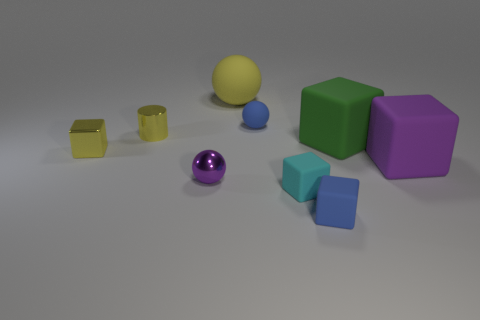What is the size of the blue object that is the same shape as the large yellow rubber object?
Provide a short and direct response. Small. Is the ball in front of the blue sphere made of the same material as the small blue object in front of the green rubber block?
Make the answer very short. No. Are there fewer shiny spheres to the left of the purple metallic object than small shiny objects?
Ensure brevity in your answer.  Yes. Is there anything else that is the same shape as the small purple shiny thing?
Provide a succinct answer. Yes. There is another big thing that is the same shape as the big green thing; what is its color?
Give a very brief answer. Purple. Do the rubber block behind the purple matte block and the purple sphere have the same size?
Offer a terse response. No. There is a matte thing to the left of the blue object that is behind the tiny blue matte block; what size is it?
Give a very brief answer. Large. Does the tiny yellow cylinder have the same material as the big block that is behind the large purple object?
Provide a succinct answer. No. Are there fewer small yellow shiny objects behind the metallic cube than large green things that are on the left side of the tiny cyan rubber block?
Provide a short and direct response. No. What color is the tiny cylinder that is the same material as the small purple object?
Keep it short and to the point. Yellow. 